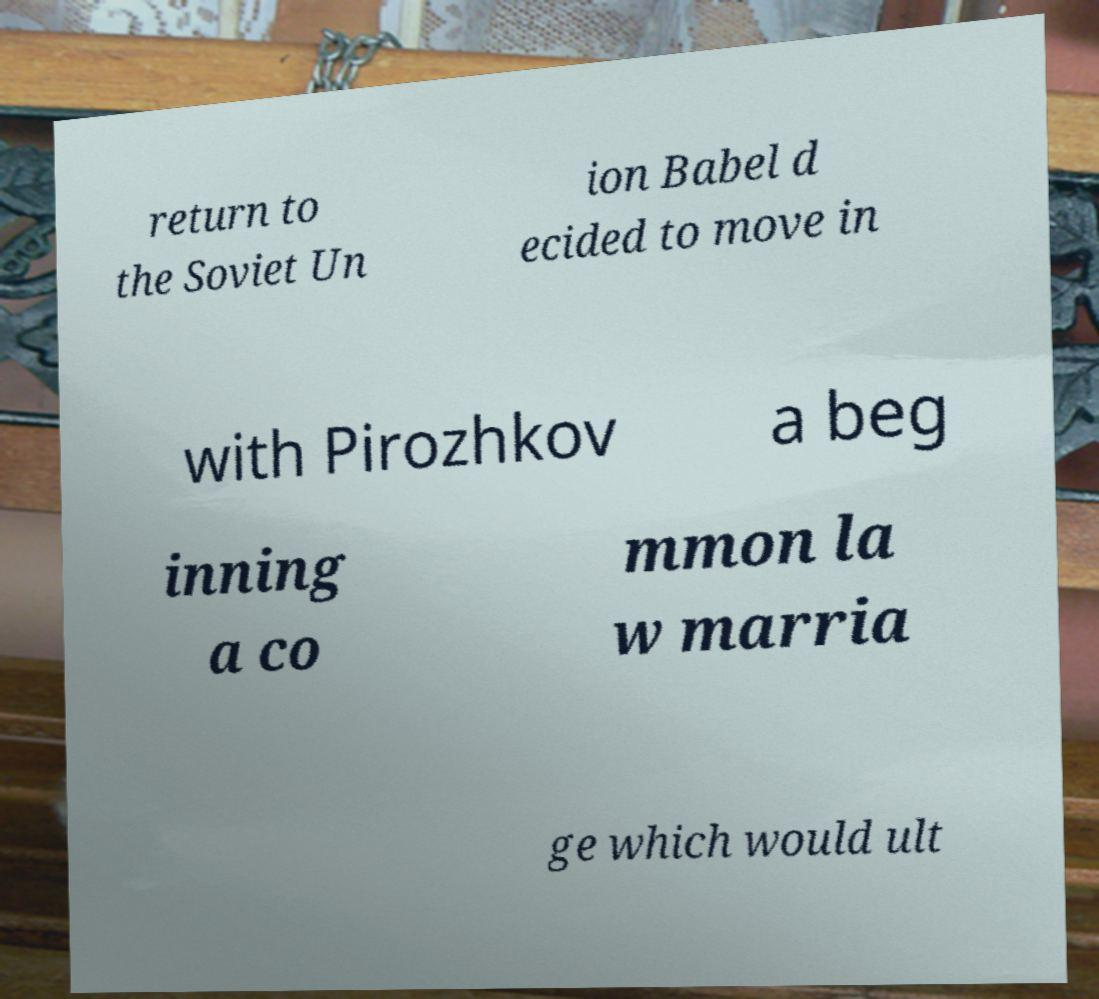Could you assist in decoding the text presented in this image and type it out clearly? return to the Soviet Un ion Babel d ecided to move in with Pirozhkov a beg inning a co mmon la w marria ge which would ult 